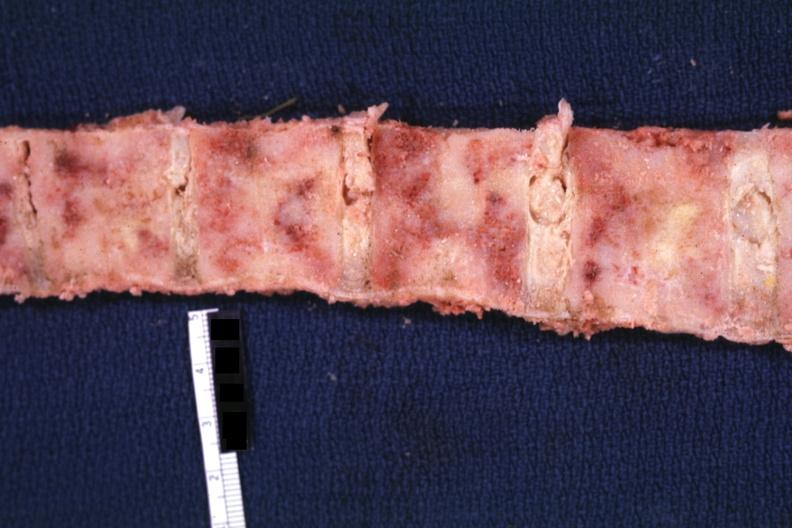what does this image show?
Answer the question using a single word or phrase. Marrow filled with obvious tumor 